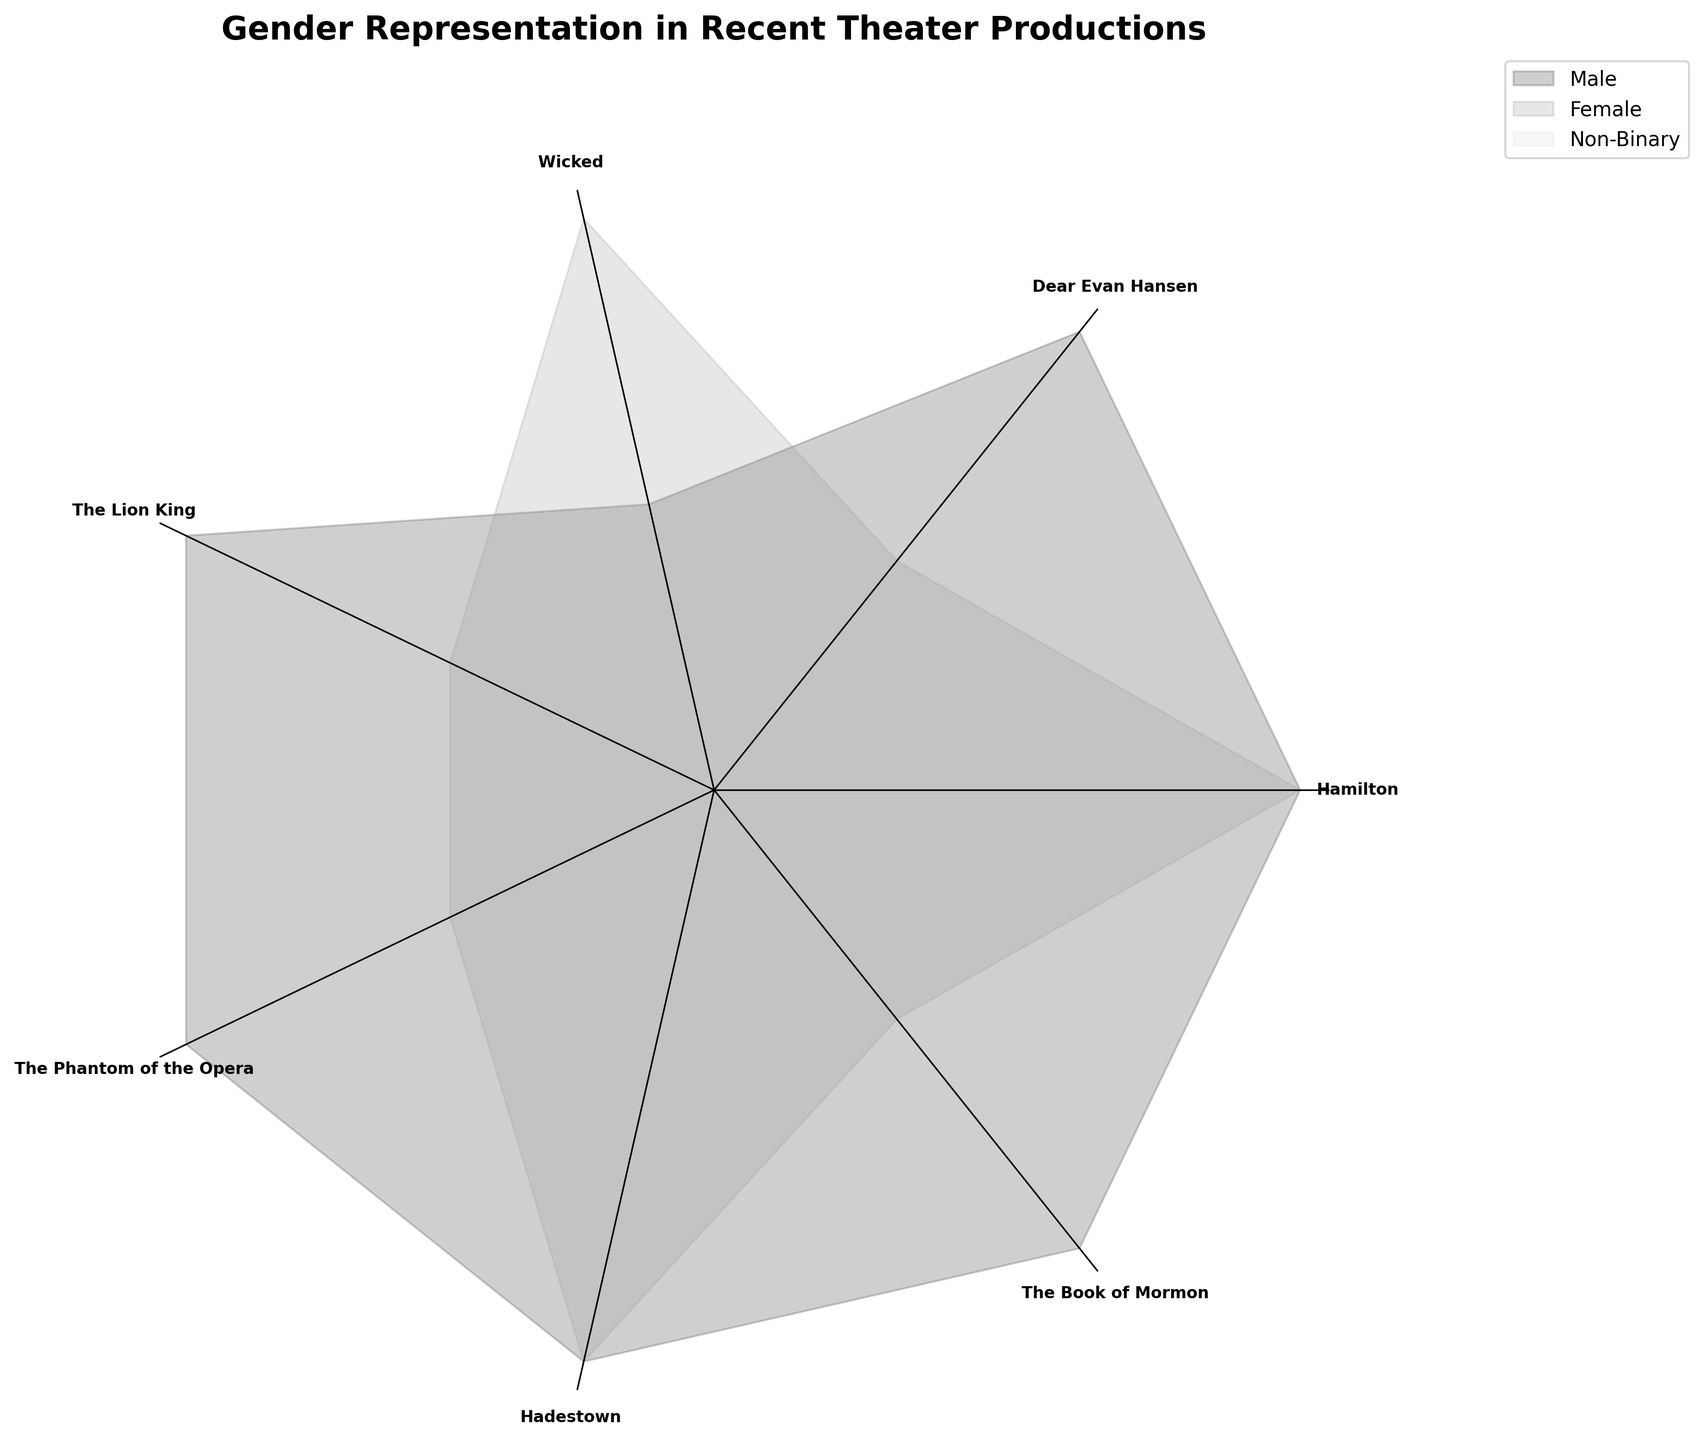What is the main title of the chart? The main title is displayed at the top of the chart, and it reads "Gender Representation in Recent Theater Productions," indicating that the chart shows the breakdown of roles by gender in various theater productions.
Answer: Gender Representation in Recent Theater Productions How many different genders are represented in the chart? By examining the legend in the chart, you can see that there are three different colors representing three genders: Male, Female, and Non-Binary.
Answer: Three Which gender has the most representation in "Hamilton"? In the polar area chart, the sections corresponding to "Hamilton" are colored according to gender. By looking at these sections, you can see that both Male and Female have an equal count.
Answer: Equal count Which theater production has the largest representation for Non-Binary gender? Refer to the segment for each theater production and identify the section colored for Non-Binary gender. The production with the largest non-binary section is "The Lion King."
Answer: The Lion King Comparing "Wicked" and "Dear Evan Hansen," which production has more female roles? In the polar area chart, find the segments for "Wicked" and "Dear Evan Hansen" and compare the sections colored for the Female gender. "Wicked" has two female roles, while "Dear Evan Hansen" has one.
Answer: Wicked What can you infer about the distribution of male roles? From the polar area chart, observe that every production has Male roles. This consistent presence across all segments suggests that Male roles are heavily represented in theater productions.
Answer: Male roles are heavily represented What is the total number of roles in "The Book of Mormon"? By looking at the section for "The Book of Mormon" on the chart, you will see three different segments filled for this production. Summing up all the different roles (regardless of gender) gives the total number: 2 Male and 1 Female equals 3.
Answer: 3 Which gender shows the least representation across all productions? Examine the total area covered by each gender in the polar area chart. The smallest section, indicating the least representation, is attributed to Non-Binary.
Answer: Non-Binary How does the gender distribution in "Hadestown" compare to "The Phantom of the Opera"? "Hadestown" and "The Phantom of the Opera" are shown with their respective sections for each gender. Both productions have two Male and two Female roles, indicating an equal distribution.
Answer: Equal distribution What insight can be drawn about Female roles across different productions? Analyzing the chart, Female roles appear in every production except "The Book of Mormon" and show variance in count, indicating varied but significant representation.
Answer: Varied but significant representation 